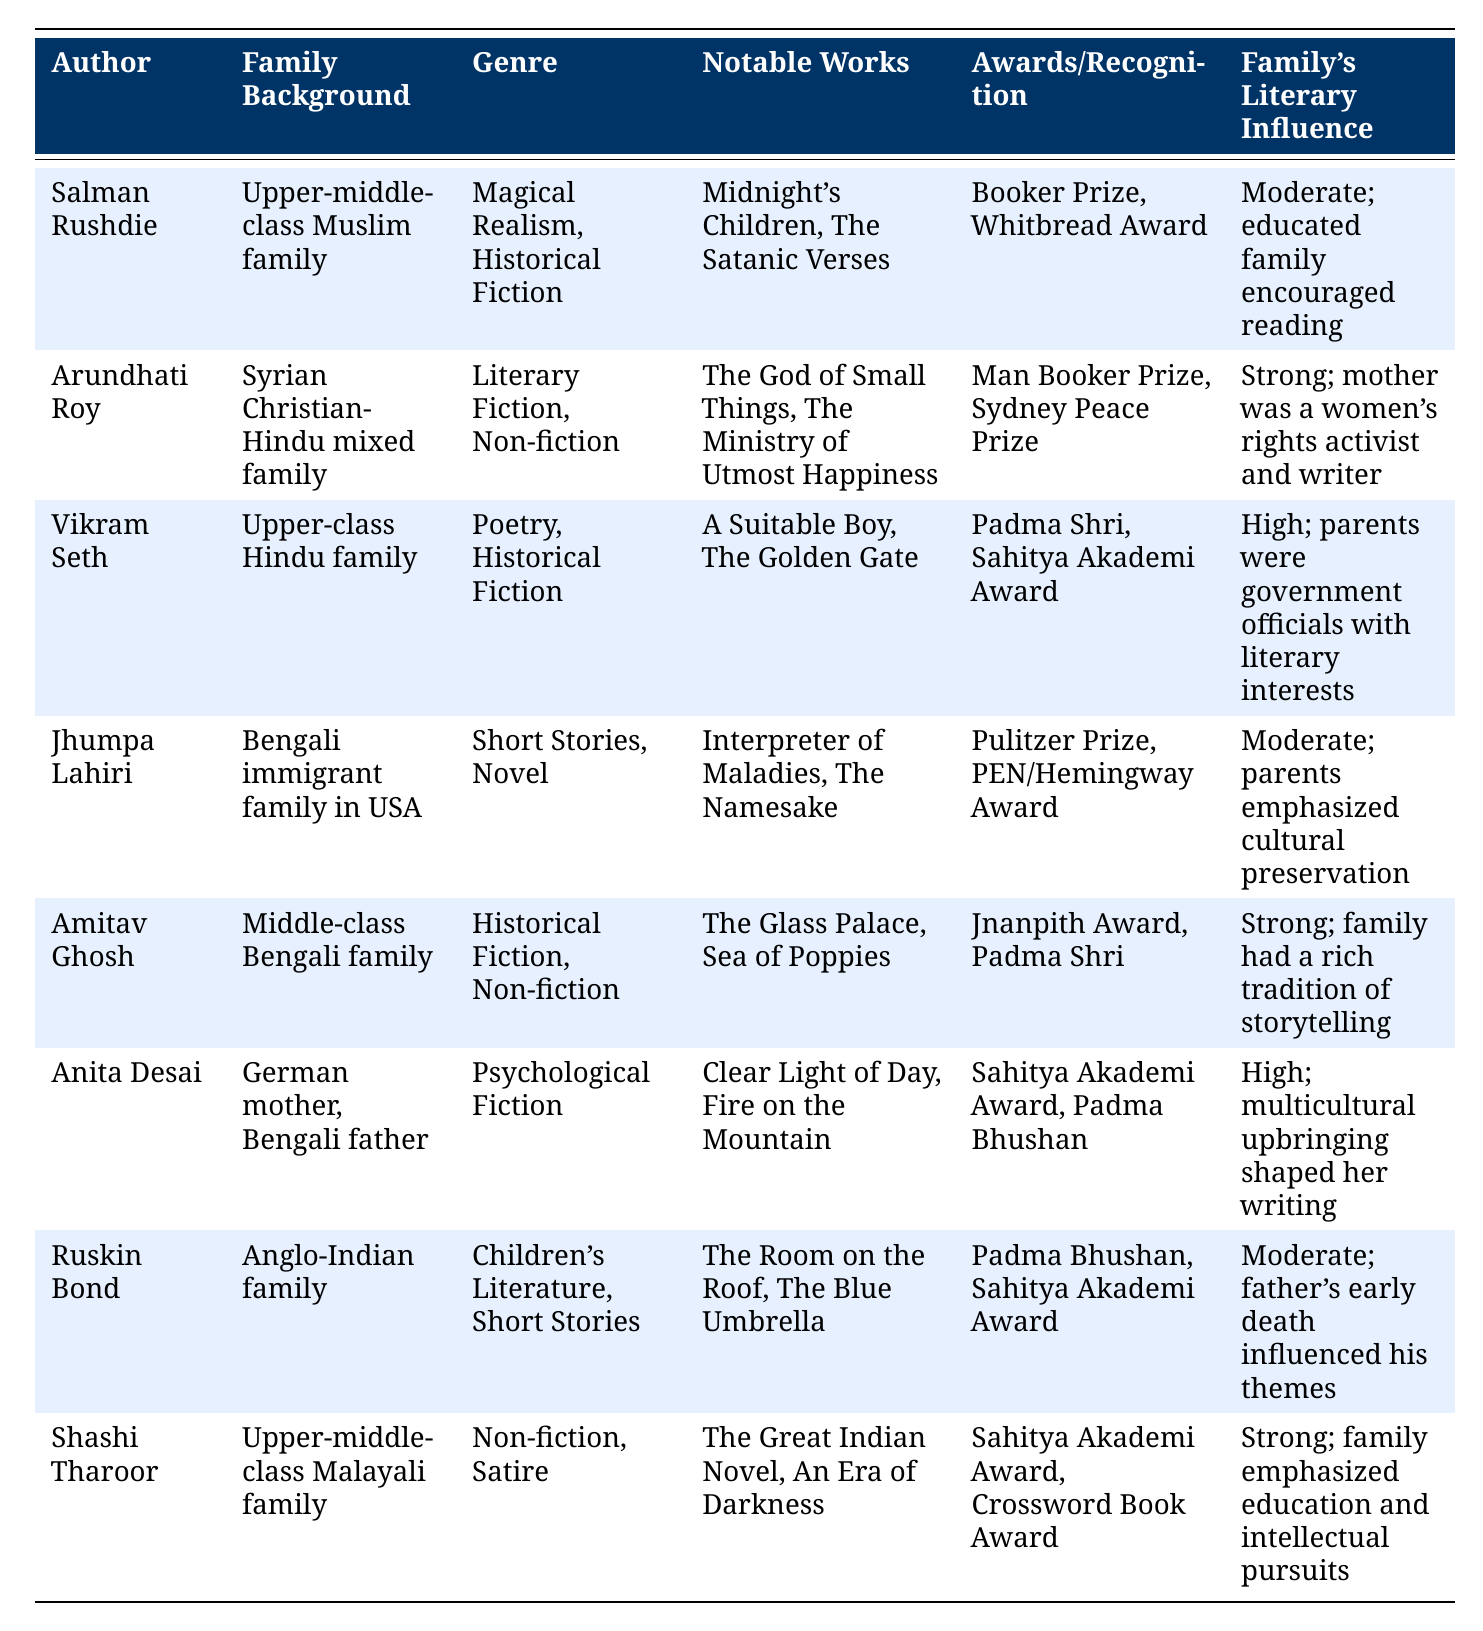What is the notable work of Arundhati Roy? The table lists Arundhati Roy’s notable works as "The God of Small Things" and "The Ministry of Utmost Happiness". This information can be retrieved directly from the respective row under "Notable Works".
Answer: The God of Small Things, The Ministry of Utmost Happiness Which author received the Booker Prize? From the table, the only author listed with the Booker Prize under "Awards/Recognition" is Salman Rushdie. This can be found in his corresponding row.
Answer: Salman Rushdie Do all authors listed have a strong family literary influence? By reviewing the "Family's Literary Influence" column, not all authors have a strong influence. For example, Salman Rushdie and Ruskin Bond have a moderate influence, while others like Arundhati Roy and Vikram Seth have a strong influence. This makes the statement false.
Answer: No Which genres are represented by Amitav Ghosh? Amitav Ghosh is listed under the "Genre" column, where his genres are Historical Fiction and Non-fiction. This information is found directly in his row.
Answer: Historical Fiction, Non-fiction Is there any author from a Bengali family background? The table lists two authors with Bengali family backgrounds: Jhumpa Lahiri, who comes from a Bengali immigrant family in the USA, and Amitav Ghosh, who is from a middle-class Bengali family. This confirms the presence of authors from Bengali backgrounds.
Answer: Yes What is the average number of notable works among the authors listed? The notable works for individual authors are: Salman Rushdie (2), Arundhati Roy (2), Vikram Seth (2), Jhumpa Lahiri (2), Amitav Ghosh (2), Anita Desai (2), Ruskin Bond (2), and Shashi Tharoor (2). There are a total of 16 notable works across 8 authors (2 per author), leading to an average of 2.
Answer: 2 Which author's family emphasized education and intellectual pursuits? This information can be found in the row under Shashi Tharoor, where it states that his family emphasized education and intellectual pursuits. By checking the "Family's Literary Influence" column, this can be confirmed.
Answer: Shashi Tharoor Which author has the highest recognition based on awards won? To determine this, one can analyze the "Awards/Recognition" column and count the types of awards. Notably, while Salman Rushdie, Arundhati Roy, and Vikram Seth have received prestigious awards, it is subjective to state who has the "highest" recognition without a specific metric. However, given the prominent awards, Salman Rushdie can be considered.
Answer: Salman Rushdie 